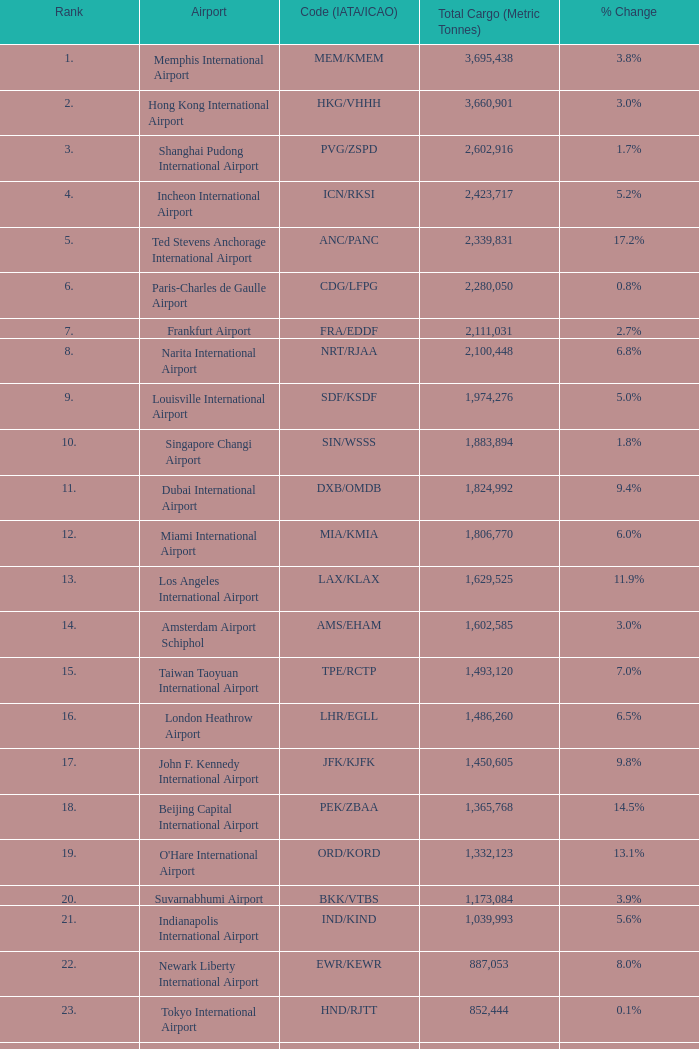Give me the full table as a dictionary. {'header': ['Rank', 'Airport', 'Code (IATA/ICAO)', 'Total Cargo (Metric Tonnes)', '% Change'], 'rows': [['1.', 'Memphis International Airport', 'MEM/KMEM', '3,695,438', '3.8%'], ['2.', 'Hong Kong International Airport', 'HKG/VHHH', '3,660,901', '3.0%'], ['3.', 'Shanghai Pudong International Airport', 'PVG/ZSPD', '2,602,916', '1.7%'], ['4.', 'Incheon International Airport', 'ICN/RKSI', '2,423,717', '5.2%'], ['5.', 'Ted Stevens Anchorage International Airport', 'ANC/PANC', '2,339,831', '17.2%'], ['6.', 'Paris-Charles de Gaulle Airport', 'CDG/LFPG', '2,280,050', '0.8%'], ['7.', 'Frankfurt Airport', 'FRA/EDDF', '2,111,031', '2.7%'], ['8.', 'Narita International Airport', 'NRT/RJAA', '2,100,448', '6.8%'], ['9.', 'Louisville International Airport', 'SDF/KSDF', '1,974,276', '5.0%'], ['10.', 'Singapore Changi Airport', 'SIN/WSSS', '1,883,894', '1.8%'], ['11.', 'Dubai International Airport', 'DXB/OMDB', '1,824,992', '9.4%'], ['12.', 'Miami International Airport', 'MIA/KMIA', '1,806,770', '6.0%'], ['13.', 'Los Angeles International Airport', 'LAX/KLAX', '1,629,525', '11.9%'], ['14.', 'Amsterdam Airport Schiphol', 'AMS/EHAM', '1,602,585', '3.0%'], ['15.', 'Taiwan Taoyuan International Airport', 'TPE/RCTP', '1,493,120', '7.0%'], ['16.', 'London Heathrow Airport', 'LHR/EGLL', '1,486,260', '6.5%'], ['17.', 'John F. Kennedy International Airport', 'JFK/KJFK', '1,450,605', '9.8%'], ['18.', 'Beijing Capital International Airport', 'PEK/ZBAA', '1,365,768', '14.5%'], ['19.', "O'Hare International Airport", 'ORD/KORD', '1,332,123', '13.1%'], ['20.', 'Suvarnabhumi Airport', 'BKK/VTBS', '1,173,084', '3.9%'], ['21.', 'Indianapolis International Airport', 'IND/KIND', '1,039,993', '5.6%'], ['22.', 'Newark Liberty International Airport', 'EWR/KEWR', '887,053', '8.0%'], ['23.', 'Tokyo International Airport', 'HND/RJTT', '852,444', '0.1%'], ['24.', 'Kansai International Airport', 'KIX/RJBB', '845,497', '0.1%'], ['25.', 'Luxembourg-Findel Airport', 'LUX/ELLX', '788,224', '8.0%'], ['26.', 'Guangzhou Baiyun International Airport', 'CAN/ZGGG', '685,868', '1.3%'], ['27.', 'Kuala Lumpur International Airport', 'KUL/WMKK', '667,495', '2.2%'], ['28.', 'Dallas-Fort Worth International Airport', 'DFW/KDFW', '660,036', '8.7%'], ['29.', 'Brussels Airport', 'BRU/EBBR', '659,054', '11.8%'], ['30.', 'Hartsfield-Jackson Atlanta International Airport', 'ATL/KATL', '655,277', '9.0%']]} What is the code for rank 10? SIN/WSSS. 